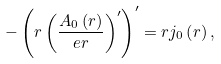Convert formula to latex. <formula><loc_0><loc_0><loc_500><loc_500>- \left ( r \left ( \frac { A _ { 0 } \left ( r \right ) } { e r } \right ) ^ { \prime } \right ) ^ { \prime } = r j _ { 0 } \left ( r \right ) ,</formula> 